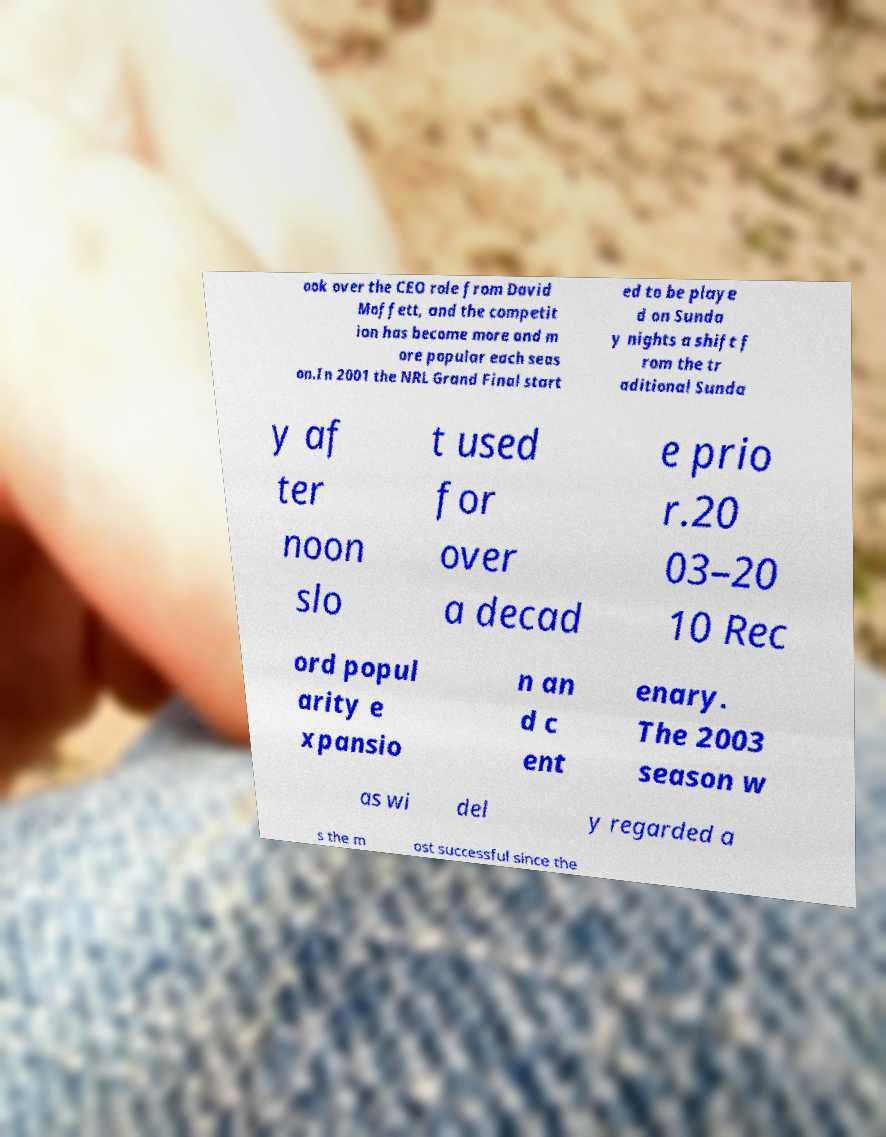There's text embedded in this image that I need extracted. Can you transcribe it verbatim? ook over the CEO role from David Moffett, and the competit ion has become more and m ore popular each seas on.In 2001 the NRL Grand Final start ed to be playe d on Sunda y nights a shift f rom the tr aditional Sunda y af ter noon slo t used for over a decad e prio r.20 03–20 10 Rec ord popul arity e xpansio n an d c ent enary. The 2003 season w as wi del y regarded a s the m ost successful since the 